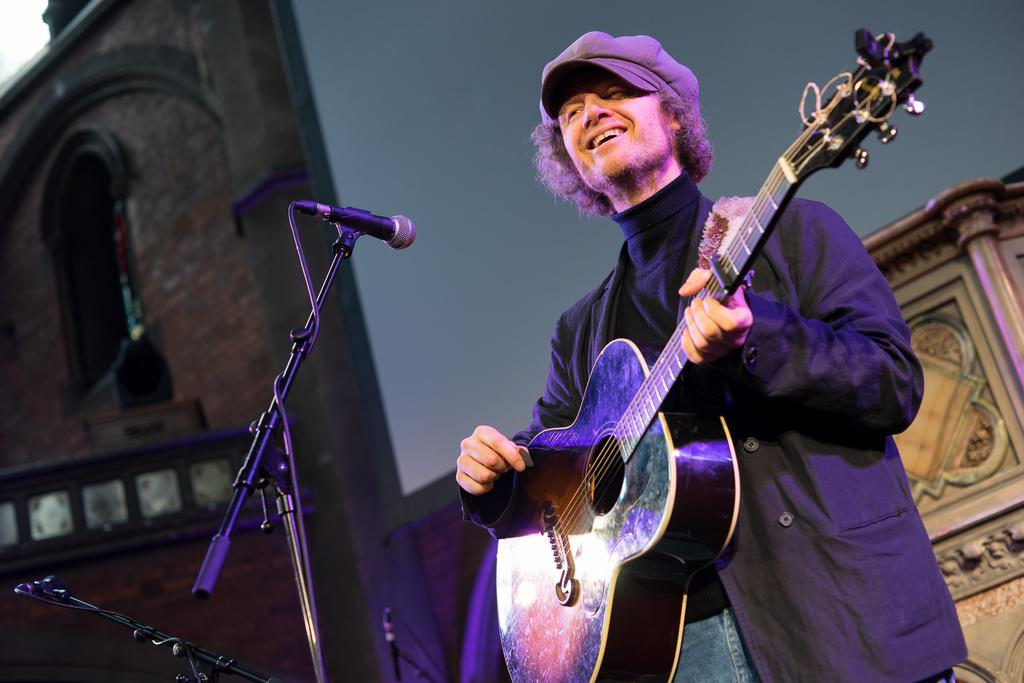Who is present in the image? There is a man in the image. What is the man doing in the image? The man is standing and smiling. What object is the man holding in the image? The man is holding a guitar. What other object can be seen in the image? There is a microphone in the image. What is the weight of the orange held by the bears in the image? There are no bears or oranges present in the image. 